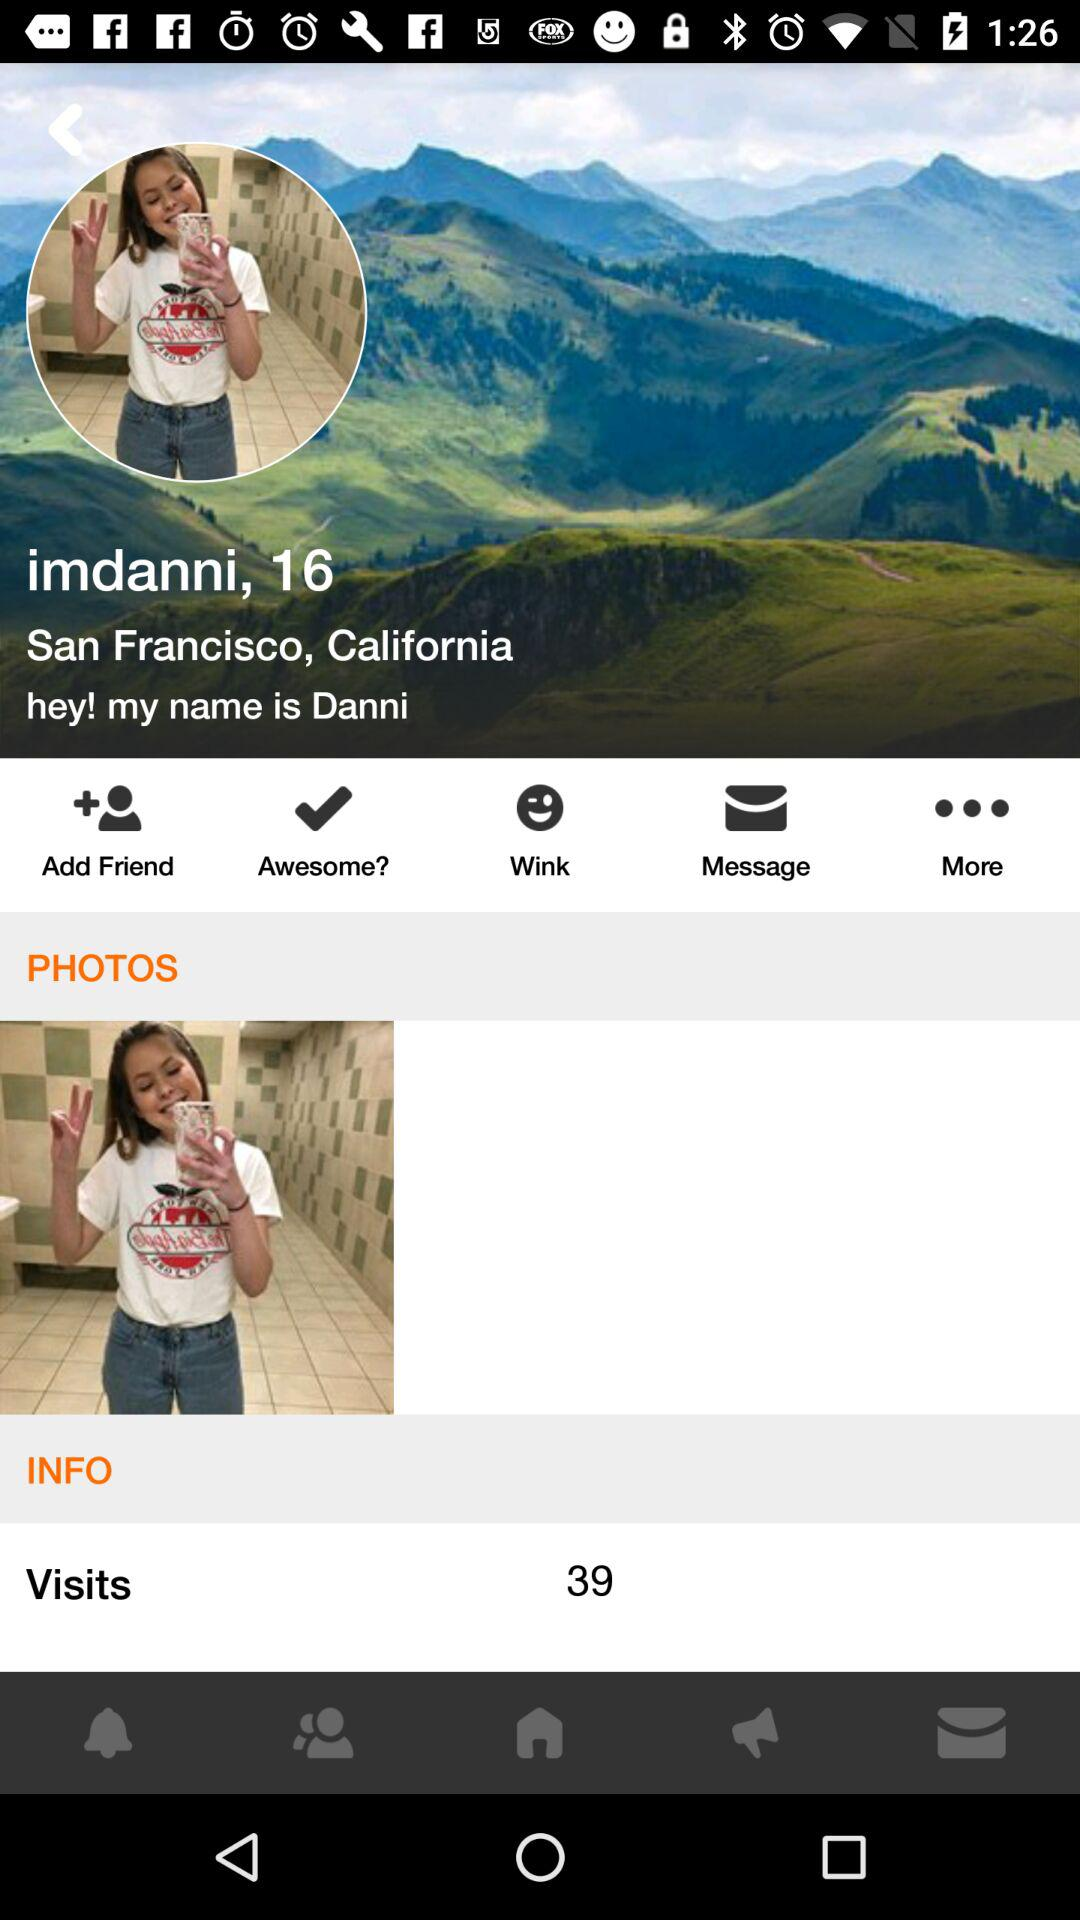What is the location? The location is San Francisco, California. 